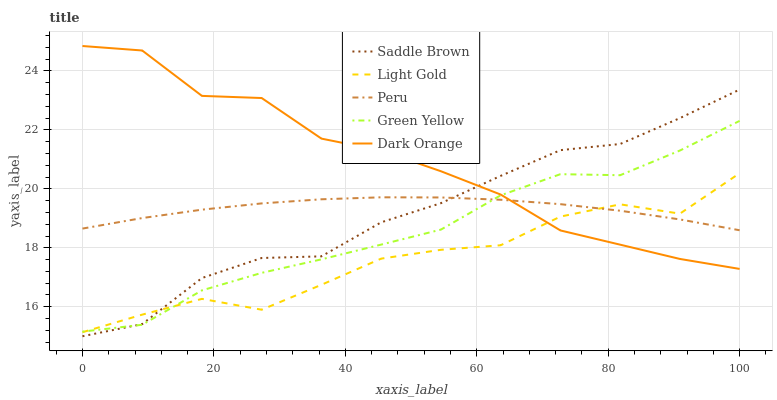Does Light Gold have the minimum area under the curve?
Answer yes or no. Yes. Does Dark Orange have the maximum area under the curve?
Answer yes or no. Yes. Does Green Yellow have the minimum area under the curve?
Answer yes or no. No. Does Green Yellow have the maximum area under the curve?
Answer yes or no. No. Is Peru the smoothest?
Answer yes or no. Yes. Is Dark Orange the roughest?
Answer yes or no. Yes. Is Green Yellow the smoothest?
Answer yes or no. No. Is Green Yellow the roughest?
Answer yes or no. No. Does Saddle Brown have the lowest value?
Answer yes or no. Yes. Does Green Yellow have the lowest value?
Answer yes or no. No. Does Dark Orange have the highest value?
Answer yes or no. Yes. Does Green Yellow have the highest value?
Answer yes or no. No. Does Light Gold intersect Peru?
Answer yes or no. Yes. Is Light Gold less than Peru?
Answer yes or no. No. Is Light Gold greater than Peru?
Answer yes or no. No. 